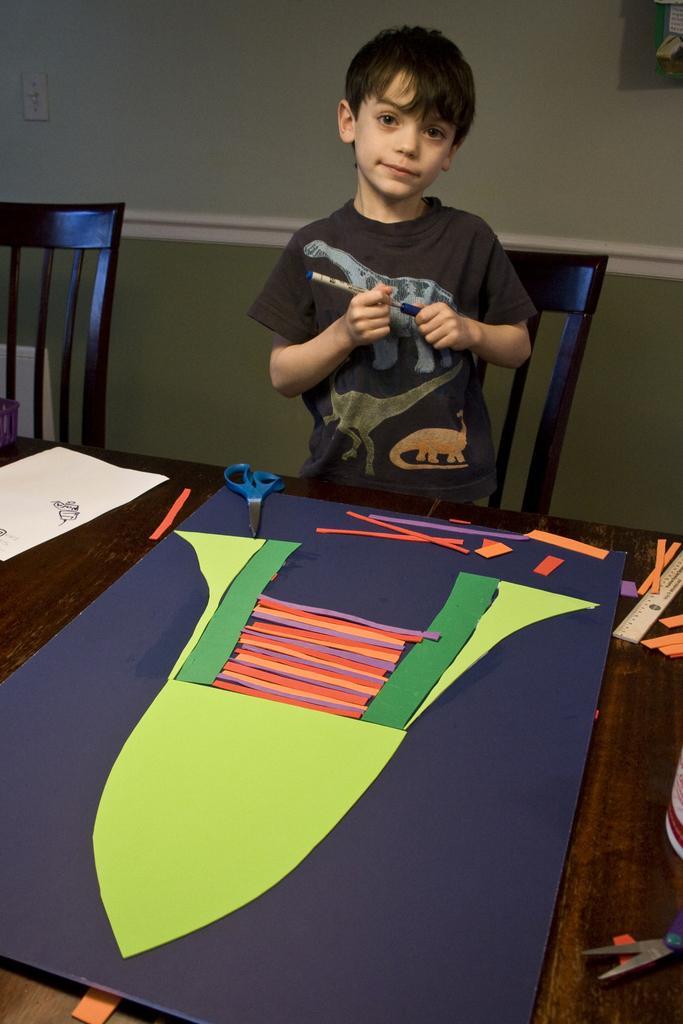Please provide a concise description of this image. In this image i can see a boy holding a pen in his hand, in front of him there is a table on which i can see piece of papers, a scale, scissors and a cardboard. In the background i can see few chairs, a wall and a switch board. 